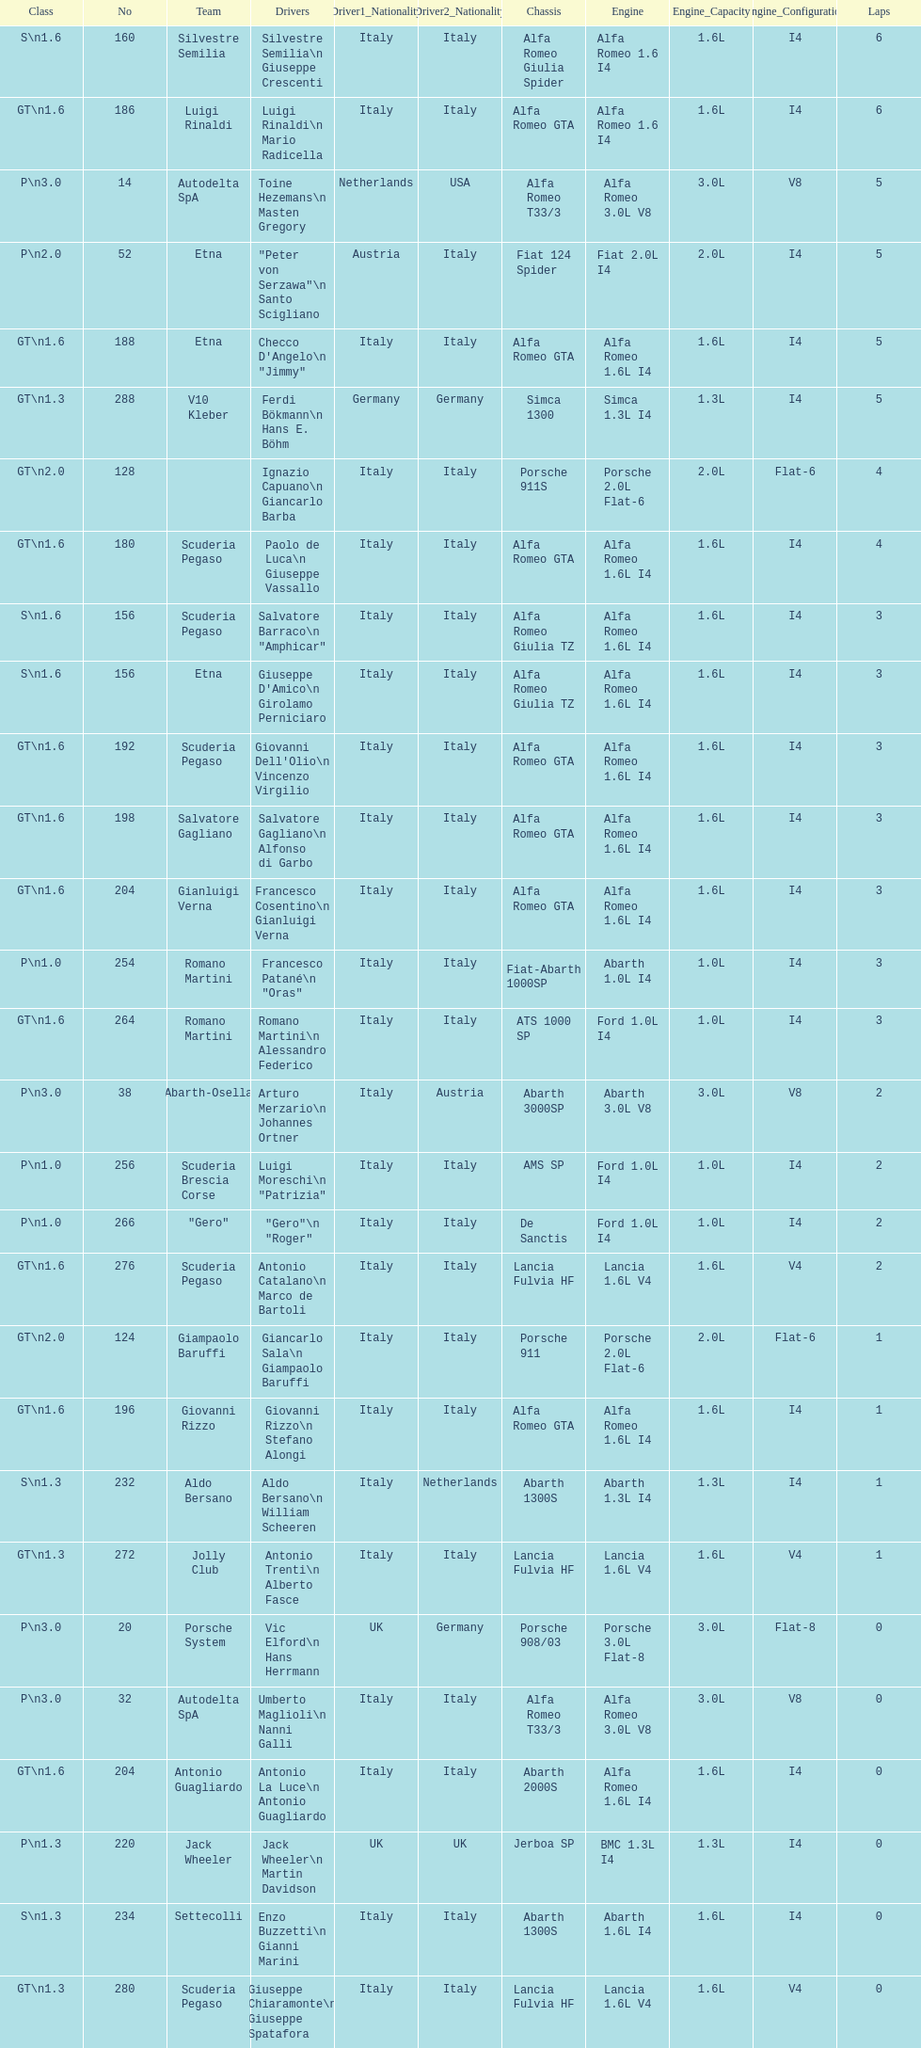How many drivers are from italy? 48. Can you give me this table as a dict? {'header': ['Class', 'No', 'Team', 'Drivers', 'Driver1_Nationality', 'Driver2_Nationality', 'Chassis', 'Engine', 'Engine_Capacity', 'Engine_Configuration', 'Laps'], 'rows': [['S\\n1.6', '160', 'Silvestre Semilia', 'Silvestre Semilia\\n Giuseppe Crescenti', 'Italy', 'Italy', 'Alfa Romeo Giulia Spider', 'Alfa Romeo 1.6 I4', '1.6L', 'I4', '6'], ['GT\\n1.6', '186', 'Luigi Rinaldi', 'Luigi Rinaldi\\n Mario Radicella', 'Italy', 'Italy', 'Alfa Romeo GTA', 'Alfa Romeo 1.6 I4', '1.6L', 'I4', '6'], ['P\\n3.0', '14', 'Autodelta SpA', 'Toine Hezemans\\n Masten Gregory', 'Netherlands', 'USA', 'Alfa Romeo T33/3', 'Alfa Romeo 3.0L V8', '3.0L', 'V8', '5'], ['P\\n2.0', '52', 'Etna', '"Peter von Serzawa"\\n Santo Scigliano', 'Austria', 'Italy', 'Fiat 124 Spider', 'Fiat 2.0L I4', '2.0L', 'I4', '5'], ['GT\\n1.6', '188', 'Etna', 'Checco D\'Angelo\\n "Jimmy"', 'Italy', 'Italy', 'Alfa Romeo GTA', 'Alfa Romeo 1.6L I4', '1.6L', 'I4', '5'], ['GT\\n1.3', '288', 'V10 Kleber', 'Ferdi Bökmann\\n Hans E. Böhm', 'Germany', 'Germany', 'Simca 1300', 'Simca 1.3L I4', '1.3L', 'I4', '5'], ['GT\\n2.0', '128', '', 'Ignazio Capuano\\n Giancarlo Barba', 'Italy', 'Italy', 'Porsche 911S', 'Porsche 2.0L Flat-6', '2.0L', 'Flat-6', '4'], ['GT\\n1.6', '180', 'Scuderia Pegaso', 'Paolo de Luca\\n Giuseppe Vassallo', 'Italy', 'Italy', 'Alfa Romeo GTA', 'Alfa Romeo 1.6L I4', '1.6L', 'I4', '4'], ['S\\n1.6', '156', 'Scuderia Pegaso', 'Salvatore Barraco\\n "Amphicar"', 'Italy', 'Italy', 'Alfa Romeo Giulia TZ', 'Alfa Romeo 1.6L I4', '1.6L', 'I4', '3'], ['S\\n1.6', '156', 'Etna', "Giuseppe D'Amico\\n Girolamo Perniciaro", 'Italy', 'Italy', 'Alfa Romeo Giulia TZ', 'Alfa Romeo 1.6L I4', '1.6L', 'I4', '3'], ['GT\\n1.6', '192', 'Scuderia Pegaso', "Giovanni Dell'Olio\\n Vincenzo Virgilio", 'Italy', 'Italy', 'Alfa Romeo GTA', 'Alfa Romeo 1.6L I4', '1.6L', 'I4', '3'], ['GT\\n1.6', '198', 'Salvatore Gagliano', 'Salvatore Gagliano\\n Alfonso di Garbo', 'Italy', 'Italy', 'Alfa Romeo GTA', 'Alfa Romeo 1.6L I4', '1.6L', 'I4', '3'], ['GT\\n1.6', '204', 'Gianluigi Verna', 'Francesco Cosentino\\n Gianluigi Verna', 'Italy', 'Italy', 'Alfa Romeo GTA', 'Alfa Romeo 1.6L I4', '1.6L', 'I4', '3'], ['P\\n1.0', '254', 'Romano Martini', 'Francesco Patané\\n "Oras"', 'Italy', 'Italy', 'Fiat-Abarth 1000SP', 'Abarth 1.0L I4', '1.0L', 'I4', '3'], ['GT\\n1.6', '264', 'Romano Martini', 'Romano Martini\\n Alessandro Federico', 'Italy', 'Italy', 'ATS 1000 SP', 'Ford 1.0L I4', '1.0L', 'I4', '3'], ['P\\n3.0', '38', 'Abarth-Osella', 'Arturo Merzario\\n Johannes Ortner', 'Italy', 'Austria', 'Abarth 3000SP', 'Abarth 3.0L V8', '3.0L', 'V8', '2'], ['P\\n1.0', '256', 'Scuderia Brescia Corse', 'Luigi Moreschi\\n "Patrizia"', 'Italy', 'Italy', 'AMS SP', 'Ford 1.0L I4', '1.0L', 'I4', '2'], ['P\\n1.0', '266', '"Gero"', '"Gero"\\n "Roger"', 'Italy', 'Italy', 'De Sanctis', 'Ford 1.0L I4', '1.0L', 'I4', '2'], ['GT\\n1.6', '276', 'Scuderia Pegaso', 'Antonio Catalano\\n Marco de Bartoli', 'Italy', 'Italy', 'Lancia Fulvia HF', 'Lancia 1.6L V4', '1.6L', 'V4', '2'], ['GT\\n2.0', '124', 'Giampaolo Baruffi', 'Giancarlo Sala\\n Giampaolo Baruffi', 'Italy', 'Italy', 'Porsche 911', 'Porsche 2.0L Flat-6', '2.0L', 'Flat-6', '1'], ['GT\\n1.6', '196', 'Giovanni Rizzo', 'Giovanni Rizzo\\n Stefano Alongi', 'Italy', 'Italy', 'Alfa Romeo GTA', 'Alfa Romeo 1.6L I4', '1.6L', 'I4', '1'], ['S\\n1.3', '232', 'Aldo Bersano', 'Aldo Bersano\\n William Scheeren', 'Italy', 'Netherlands', 'Abarth 1300S', 'Abarth 1.3L I4', '1.3L', 'I4', '1'], ['GT\\n1.3', '272', 'Jolly Club', 'Antonio Trenti\\n Alberto Fasce', 'Italy', 'Italy', 'Lancia Fulvia HF', 'Lancia 1.6L V4', '1.6L', 'V4', '1'], ['P\\n3.0', '20', 'Porsche System', 'Vic Elford\\n Hans Herrmann', 'UK', 'Germany', 'Porsche 908/03', 'Porsche 3.0L Flat-8', '3.0L', 'Flat-8', '0'], ['P\\n3.0', '32', 'Autodelta SpA', 'Umberto Maglioli\\n Nanni Galli', 'Italy', 'Italy', 'Alfa Romeo T33/3', 'Alfa Romeo 3.0L V8', '3.0L', 'V8', '0'], ['GT\\n1.6', '204', 'Antonio Guagliardo', 'Antonio La Luce\\n Antonio Guagliardo', 'Italy', 'Italy', 'Abarth 2000S', 'Alfa Romeo 1.6L I4', '1.6L', 'I4', '0'], ['P\\n1.3', '220', 'Jack Wheeler', 'Jack Wheeler\\n Martin Davidson', 'UK', 'UK', 'Jerboa SP', 'BMC 1.3L I4', '1.3L', 'I4', '0'], ['S\\n1.3', '234', 'Settecolli', 'Enzo Buzzetti\\n Gianni Marini', 'Italy', 'Italy', 'Abarth 1300S', 'Abarth 1.6L I4', '1.6L', 'I4', '0'], ['GT\\n1.3', '280', 'Scuderia Pegaso', 'Giuseppe Chiaramonte\\n Giuseppe Spatafora', 'Italy', 'Italy', 'Lancia Fulvia HF', 'Lancia 1.6L V4', '1.6L', 'V4', '0']]} 